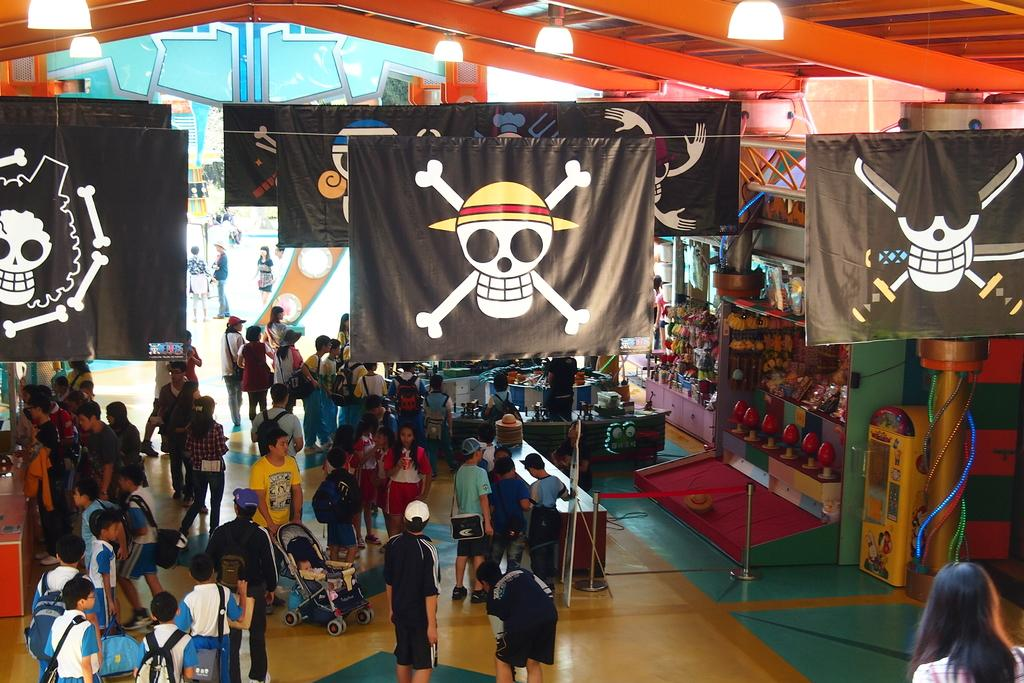Who is present in the image? There are children in the image. Where are the children located? The children are standing in a shop. What can be seen at the top of the image? There are black color banners at the top of the image. What type of beginner's club is being advertised on the banners in the image? There is no mention of a club or any advertisement in the image; it only shows children standing in a shop with black color banners at the top. 